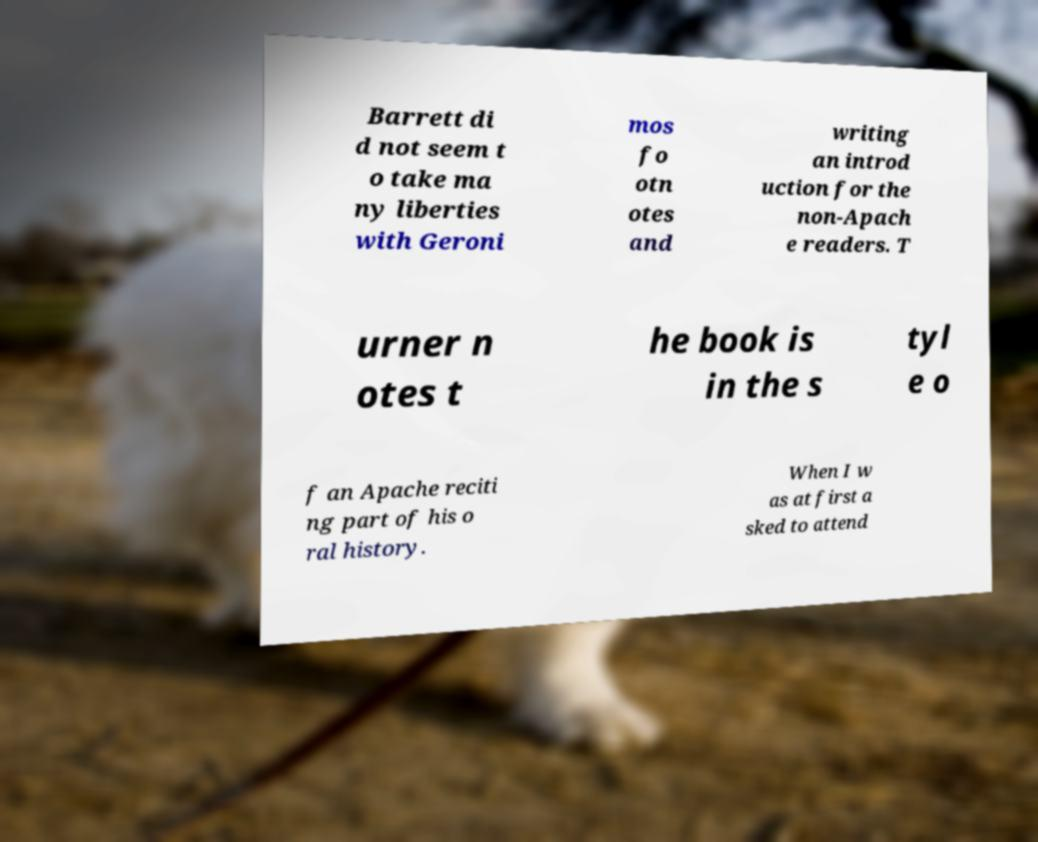Please read and relay the text visible in this image. What does it say? Barrett di d not seem t o take ma ny liberties with Geroni mos fo otn otes and writing an introd uction for the non-Apach e readers. T urner n otes t he book is in the s tyl e o f an Apache reciti ng part of his o ral history. When I w as at first a sked to attend 